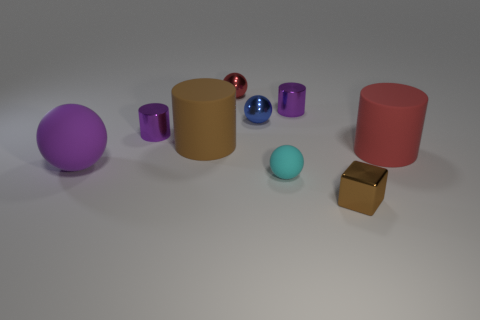Subtract 1 cylinders. How many cylinders are left? 3 Add 1 brown shiny cubes. How many objects exist? 10 Subtract all green balls. Subtract all red cylinders. How many balls are left? 4 Subtract all blocks. How many objects are left? 8 Subtract all brown rubber cylinders. Subtract all large red blocks. How many objects are left? 8 Add 4 red metallic objects. How many red metallic objects are left? 5 Add 8 brown metallic objects. How many brown metallic objects exist? 9 Subtract 1 red spheres. How many objects are left? 8 